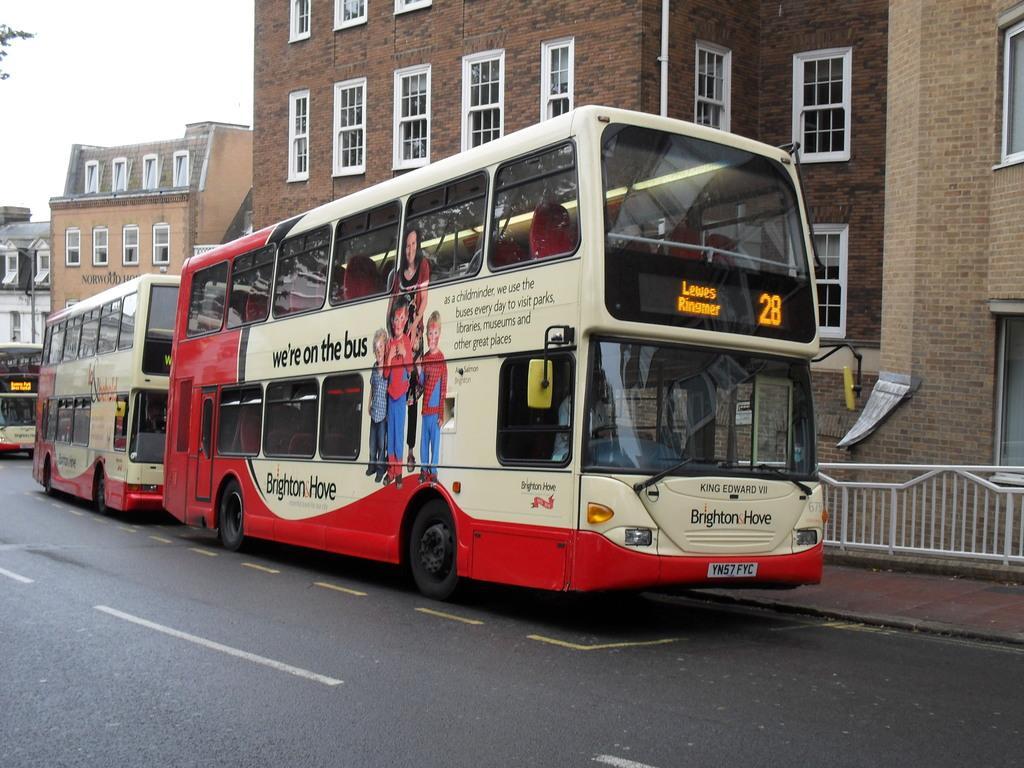How would you summarize this image in a sentence or two? In this image we can see some buses on the road. We can also see a signboard to a pole, a metal fence, some buildings with windows and the sky which looks cloudy. 